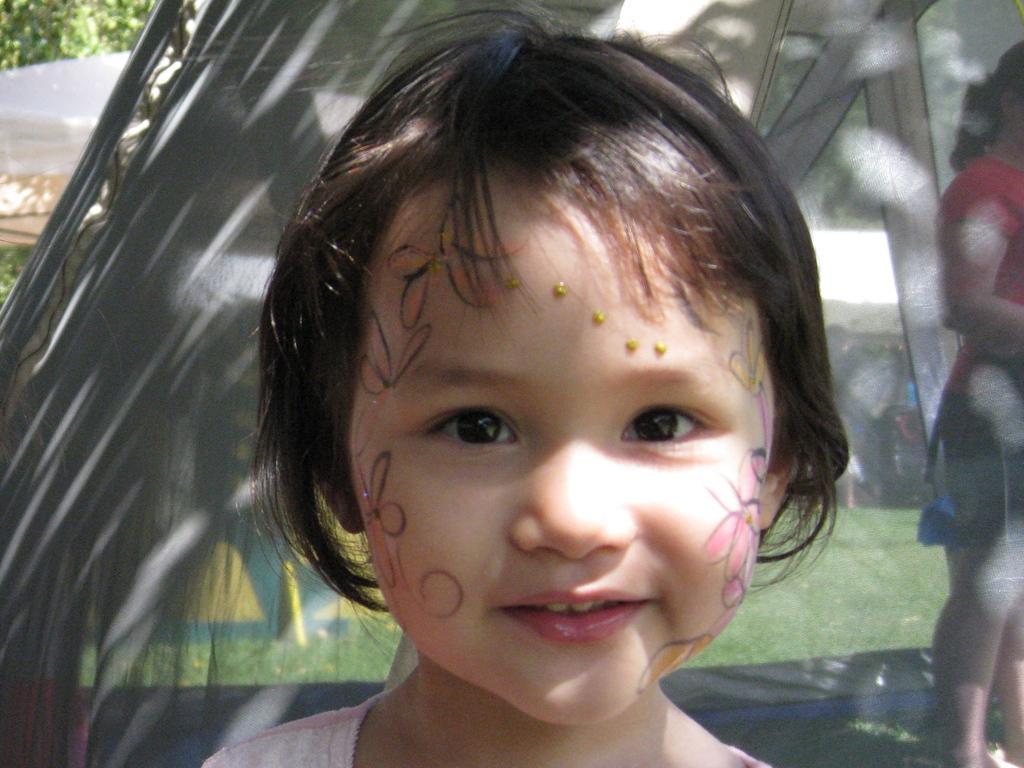Describe this image in one or two sentences. In this image we can see a child. On the backside we can see a girl standing inside a tent. We can also see some grass and trees. 